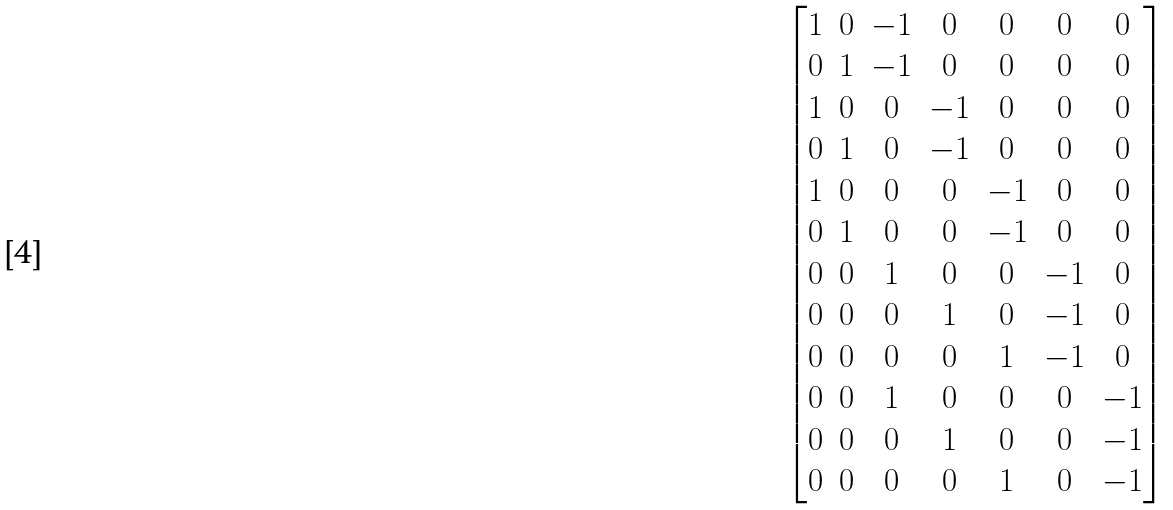Convert formula to latex. <formula><loc_0><loc_0><loc_500><loc_500>\begin{bmatrix} 1 & 0 & - 1 & 0 & 0 & 0 & 0 \\ 0 & 1 & - 1 & 0 & 0 & 0 & 0 \\ 1 & 0 & 0 & - 1 & 0 & 0 & 0 \\ 0 & 1 & 0 & - 1 & 0 & 0 & 0 \\ 1 & 0 & 0 & 0 & - 1 & 0 & 0 \\ 0 & 1 & 0 & 0 & - 1 & 0 & 0 \\ 0 & 0 & 1 & 0 & 0 & - 1 & 0 \\ 0 & 0 & 0 & 1 & 0 & - 1 & 0 \\ 0 & 0 & 0 & 0 & 1 & - 1 & 0 \\ 0 & 0 & 1 & 0 & 0 & 0 & - 1 \\ 0 & 0 & 0 & 1 & 0 & 0 & - 1 \\ 0 & 0 & 0 & 0 & 1 & 0 & - 1 \end{bmatrix}</formula> 